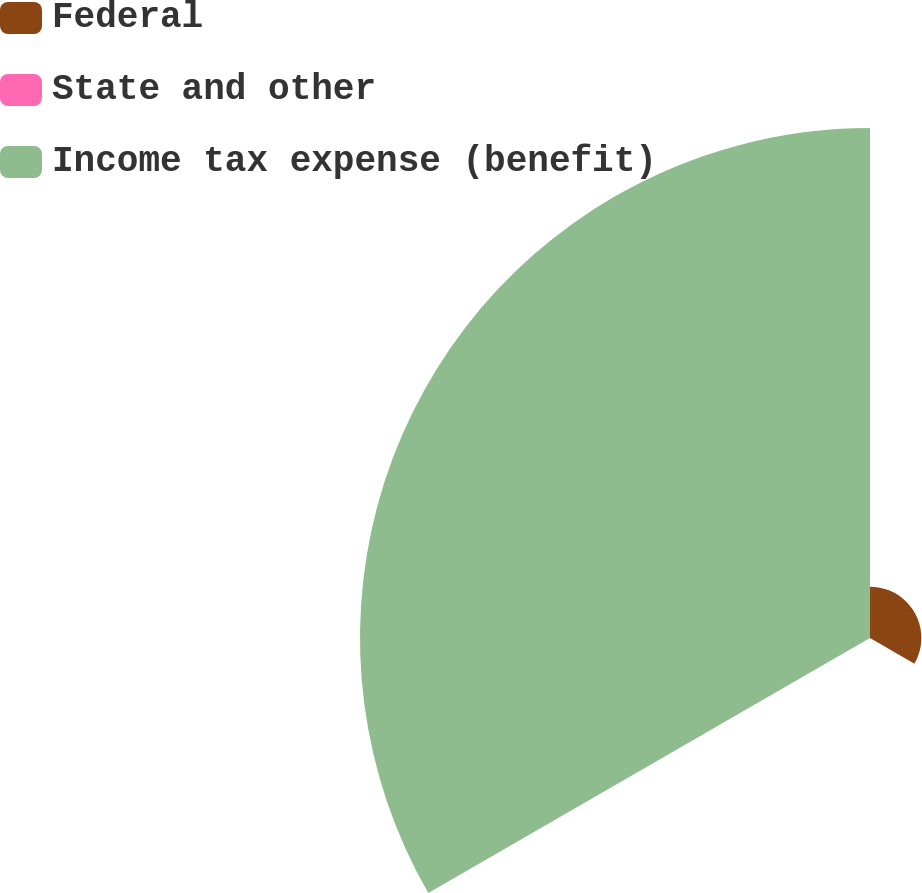<chart> <loc_0><loc_0><loc_500><loc_500><pie_chart><fcel>Federal<fcel>State and other<fcel>Income tax expense (benefit)<nl><fcel>9.14%<fcel>0.07%<fcel>90.79%<nl></chart> 